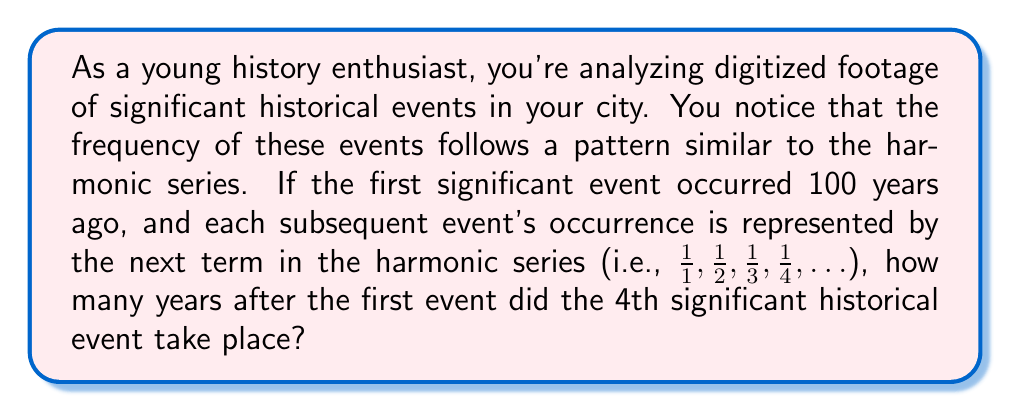Help me with this question. Let's approach this step-by-step:

1) The harmonic series is represented as:

   $$\sum_{n=1}^{\infty} \frac{1}{n} = 1 + \frac{1}{2} + \frac{1}{3} + \frac{1}{4} + ...$$

2) We're interested in the 4th term, so we need to sum the first 4 terms:

   $$S_4 = 1 + \frac{1}{2} + \frac{1}{3} + \frac{1}{4}$$

3) Let's calculate this sum:

   $$S_4 = 1 + 0.5 + 0.3333... + 0.25 = 2.0833...$$

4) This sum represents the total fraction of the 100-year period that has passed when the 4th event occurs.

5) To find how many years after the first event the 4th event occurred, we need to subtract 1 (representing the first event) from this sum and multiply by 100:

   $$(S_4 - 1) * 100 = (2.0833... - 1) * 100 = 1.0833... * 100 = 108.33...$$

6) Rounding to the nearest year, we get 108 years.
Answer: The 4th significant historical event took place approximately 108 years after the first event. 